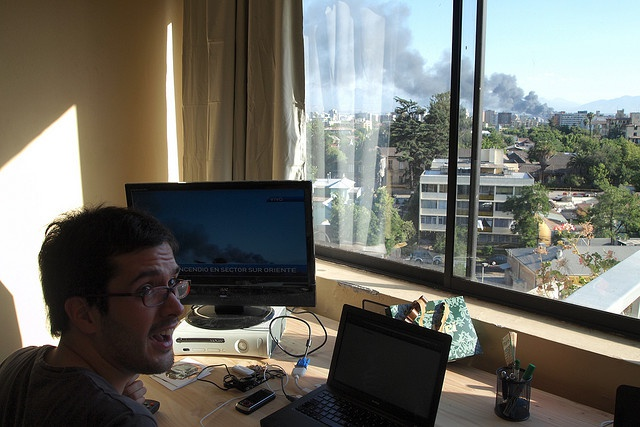Describe the objects in this image and their specific colors. I can see people in black and gray tones, tv in black, navy, gray, and darkgray tones, laptop in black, gray, and darkblue tones, tv in black tones, and cup in black, gray, and maroon tones in this image. 